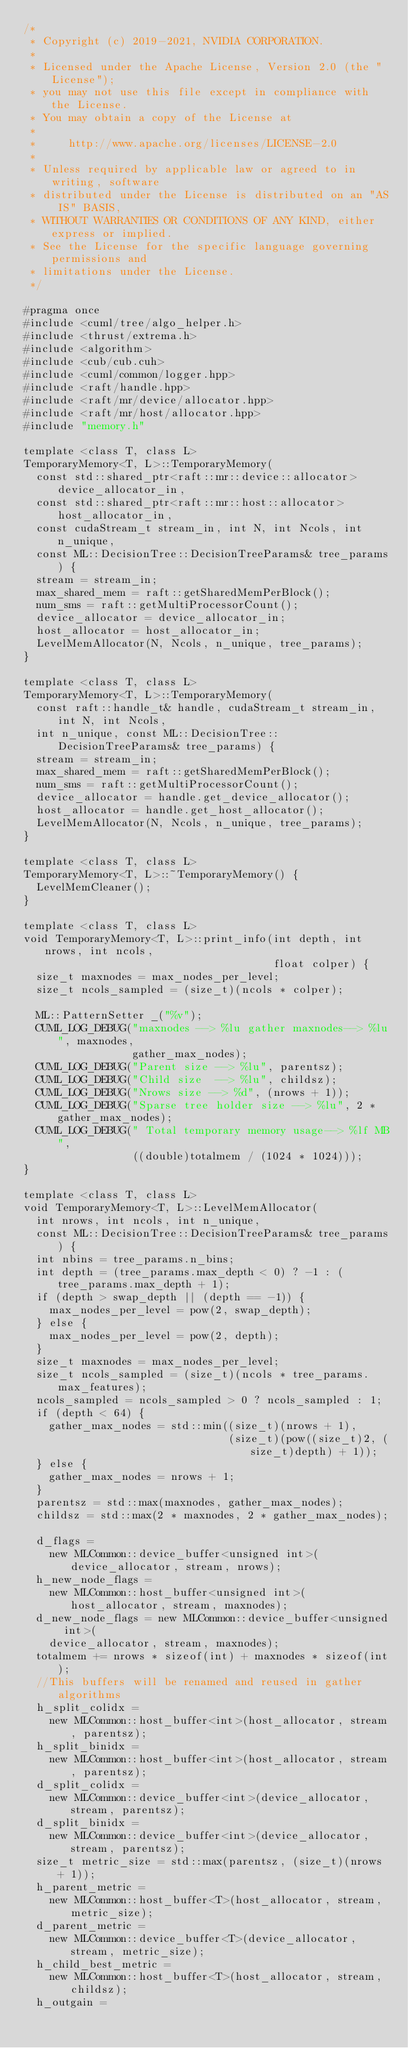Convert code to text. <code><loc_0><loc_0><loc_500><loc_500><_Cuda_>/*
 * Copyright (c) 2019-2021, NVIDIA CORPORATION.
 *
 * Licensed under the Apache License, Version 2.0 (the "License");
 * you may not use this file except in compliance with the License.
 * You may obtain a copy of the License at
 *
 *     http://www.apache.org/licenses/LICENSE-2.0
 *
 * Unless required by applicable law or agreed to in writing, software
 * distributed under the License is distributed on an "AS IS" BASIS,
 * WITHOUT WARRANTIES OR CONDITIONS OF ANY KIND, either express or implied.
 * See the License for the specific language governing permissions and
 * limitations under the License.
 */

#pragma once
#include <cuml/tree/algo_helper.h>
#include <thrust/extrema.h>
#include <algorithm>
#include <cub/cub.cuh>
#include <cuml/common/logger.hpp>
#include <raft/handle.hpp>
#include <raft/mr/device/allocator.hpp>
#include <raft/mr/host/allocator.hpp>
#include "memory.h"

template <class T, class L>
TemporaryMemory<T, L>::TemporaryMemory(
  const std::shared_ptr<raft::mr::device::allocator> device_allocator_in,
  const std::shared_ptr<raft::mr::host::allocator> host_allocator_in,
  const cudaStream_t stream_in, int N, int Ncols, int n_unique,
  const ML::DecisionTree::DecisionTreeParams& tree_params) {
  stream = stream_in;
  max_shared_mem = raft::getSharedMemPerBlock();
  num_sms = raft::getMultiProcessorCount();
  device_allocator = device_allocator_in;
  host_allocator = host_allocator_in;
  LevelMemAllocator(N, Ncols, n_unique, tree_params);
}

template <class T, class L>
TemporaryMemory<T, L>::TemporaryMemory(
  const raft::handle_t& handle, cudaStream_t stream_in, int N, int Ncols,
  int n_unique, const ML::DecisionTree::DecisionTreeParams& tree_params) {
  stream = stream_in;
  max_shared_mem = raft::getSharedMemPerBlock();
  num_sms = raft::getMultiProcessorCount();
  device_allocator = handle.get_device_allocator();
  host_allocator = handle.get_host_allocator();
  LevelMemAllocator(N, Ncols, n_unique, tree_params);
}

template <class T, class L>
TemporaryMemory<T, L>::~TemporaryMemory() {
  LevelMemCleaner();
}

template <class T, class L>
void TemporaryMemory<T, L>::print_info(int depth, int nrows, int ncols,
                                       float colper) {
  size_t maxnodes = max_nodes_per_level;
  size_t ncols_sampled = (size_t)(ncols * colper);

  ML::PatternSetter _("%v");
  CUML_LOG_DEBUG("maxnodes --> %lu gather maxnodes--> %lu", maxnodes,
                 gather_max_nodes);
  CUML_LOG_DEBUG("Parent size --> %lu", parentsz);
  CUML_LOG_DEBUG("Child size  --> %lu", childsz);
  CUML_LOG_DEBUG("Nrows size --> %d", (nrows + 1));
  CUML_LOG_DEBUG("Sparse tree holder size --> %lu", 2 * gather_max_nodes);
  CUML_LOG_DEBUG(" Total temporary memory usage--> %lf MB",
                 ((double)totalmem / (1024 * 1024)));
}

template <class T, class L>
void TemporaryMemory<T, L>::LevelMemAllocator(
  int nrows, int ncols, int n_unique,
  const ML::DecisionTree::DecisionTreeParams& tree_params) {
  int nbins = tree_params.n_bins;
  int depth = (tree_params.max_depth < 0) ? -1 : (tree_params.max_depth + 1);
  if (depth > swap_depth || (depth == -1)) {
    max_nodes_per_level = pow(2, swap_depth);
  } else {
    max_nodes_per_level = pow(2, depth);
  }
  size_t maxnodes = max_nodes_per_level;
  size_t ncols_sampled = (size_t)(ncols * tree_params.max_features);
  ncols_sampled = ncols_sampled > 0 ? ncols_sampled : 1;
  if (depth < 64) {
    gather_max_nodes = std::min((size_t)(nrows + 1),
                                (size_t)(pow((size_t)2, (size_t)depth) + 1));
  } else {
    gather_max_nodes = nrows + 1;
  }
  parentsz = std::max(maxnodes, gather_max_nodes);
  childsz = std::max(2 * maxnodes, 2 * gather_max_nodes);

  d_flags =
    new MLCommon::device_buffer<unsigned int>(device_allocator, stream, nrows);
  h_new_node_flags =
    new MLCommon::host_buffer<unsigned int>(host_allocator, stream, maxnodes);
  d_new_node_flags = new MLCommon::device_buffer<unsigned int>(
    device_allocator, stream, maxnodes);
  totalmem += nrows * sizeof(int) + maxnodes * sizeof(int);
  //This buffers will be renamed and reused in gather algorithms
  h_split_colidx =
    new MLCommon::host_buffer<int>(host_allocator, stream, parentsz);
  h_split_binidx =
    new MLCommon::host_buffer<int>(host_allocator, stream, parentsz);
  d_split_colidx =
    new MLCommon::device_buffer<int>(device_allocator, stream, parentsz);
  d_split_binidx =
    new MLCommon::device_buffer<int>(device_allocator, stream, parentsz);
  size_t metric_size = std::max(parentsz, (size_t)(nrows + 1));
  h_parent_metric =
    new MLCommon::host_buffer<T>(host_allocator, stream, metric_size);
  d_parent_metric =
    new MLCommon::device_buffer<T>(device_allocator, stream, metric_size);
  h_child_best_metric =
    new MLCommon::host_buffer<T>(host_allocator, stream, childsz);
  h_outgain =</code> 